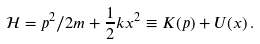Convert formula to latex. <formula><loc_0><loc_0><loc_500><loc_500>\mathcal { H } = p ^ { 2 } / 2 m + \frac { 1 } { 2 } k x ^ { 2 } \equiv K ( p ) + U ( x ) \, .</formula> 